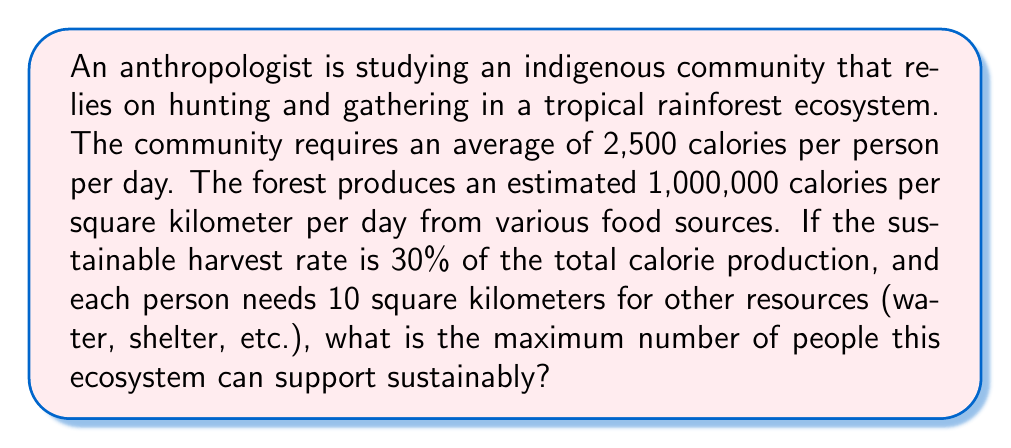Solve this math problem. Let's approach this problem step-by-step:

1) First, calculate the sustainable calorie production per square kilometer per day:
   $$\text{Sustainable calories} = 1,000,000 \times 0.30 = 300,000 \text{ calories/km}^2\text{/day}$$

2) Calculate the area needed to support one person's calorie needs:
   $$\text{Area for calories} = \frac{2,500 \text{ calories/person/day}}{300,000 \text{ calories/km}^2\text{/day}} = \frac{1}{120} \text{ km}^2\text{/person}$$

3) Add the area needed for other resources:
   $$\text{Total area per person} = \frac{1}{120} + 10 = \frac{1201}{120} \text{ km}^2\text{/person}$$

4) The carrying capacity is the reciprocal of the total area per person:
   $$\text{Carrying capacity} = \frac{120}{1201} \approx 0.0999 \text{ people/km}^2$$

5) To get the total number of people, we need to know the total area of the ecosystem. However, this information isn't provided in the question. Instead, we can express the answer in terms of the ecosystem area A:

   $$\text{Maximum number of people} = 0.0999 \times A$$

   Where A is the total area of the ecosystem in square kilometers.
Answer: $0.0999A$ people, where $A$ is the ecosystem area in km² 